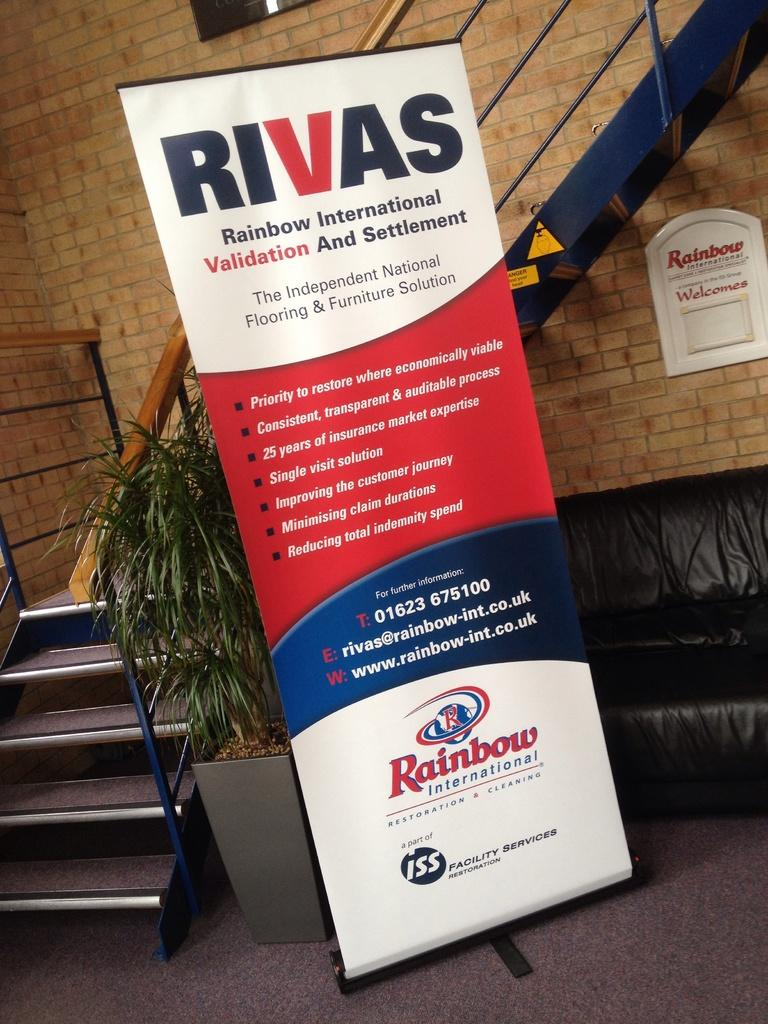What is located in front of the staircase in the image? There is a banner in front of the staircase. What can be seen in the middle of the image? There is a plant in the middle of the image. What type of furniture is on the right side of the image? There is a sofa on the right side of the image. How many ladybugs are crawling on the sofa in the image? There are no ladybugs present on the sofa in the image. What type of butter is spread on the banner in the image? There is no butter present on the banner in the image. 